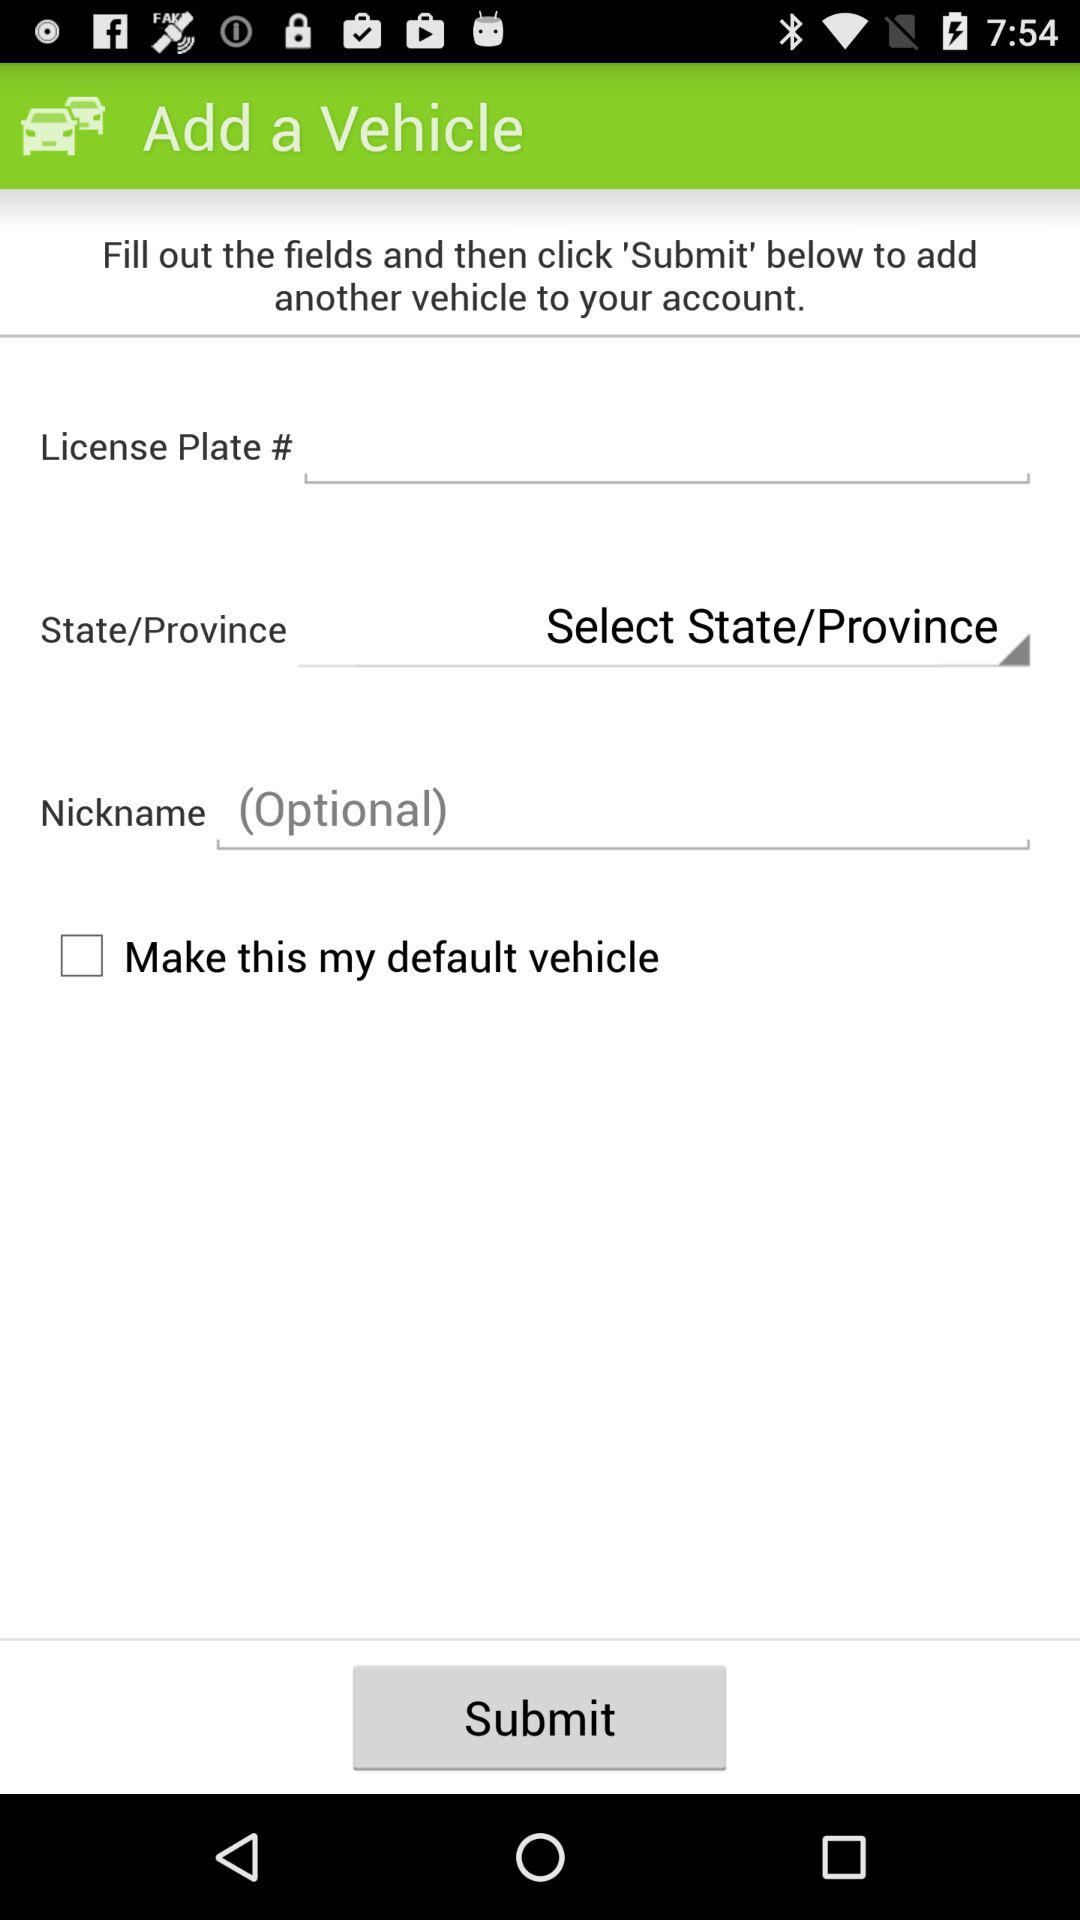How many fields are there that require a user to input text?
Answer the question using a single word or phrase. 3 